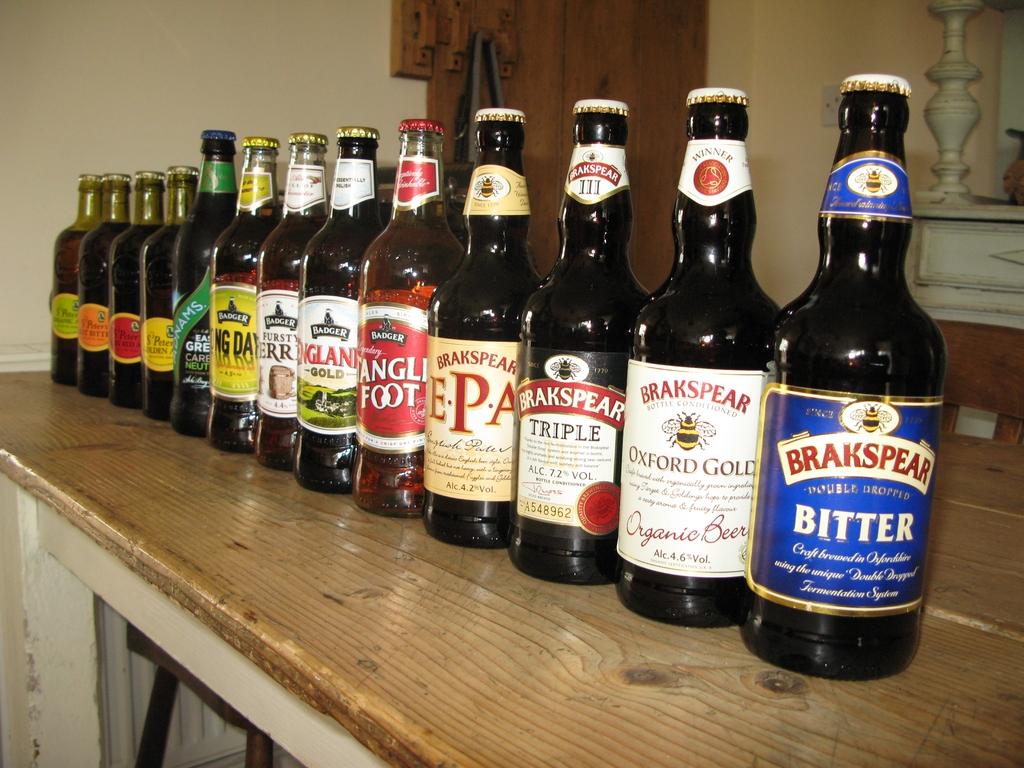What brand of beer is the closest bottle?
Ensure brevity in your answer.  Brakspear. 